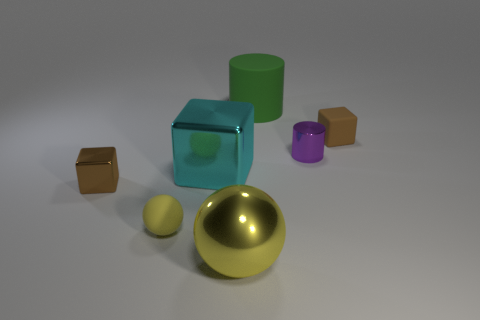The cylinder that is made of the same material as the large ball is what size?
Provide a succinct answer. Small. Are there any other things of the same color as the big matte object?
Your answer should be very brief. No. Do the tiny shiny thing that is left of the green matte object and the block that is behind the purple metal cylinder have the same color?
Offer a terse response. Yes. There is a large object that is right of the big yellow shiny thing; what is its color?
Give a very brief answer. Green. There is a sphere to the left of the cyan thing; is it the same size as the yellow metal sphere?
Offer a very short reply. No. Are there fewer cyan things than small brown things?
Give a very brief answer. Yes. There is a small object that is the same color as the big metallic sphere; what is its shape?
Your response must be concise. Sphere. How many tiny matte things are on the right side of the large green cylinder?
Your response must be concise. 1. Do the cyan object and the big green matte thing have the same shape?
Give a very brief answer. No. What number of things are in front of the tiny sphere and right of the big rubber object?
Give a very brief answer. 0. 